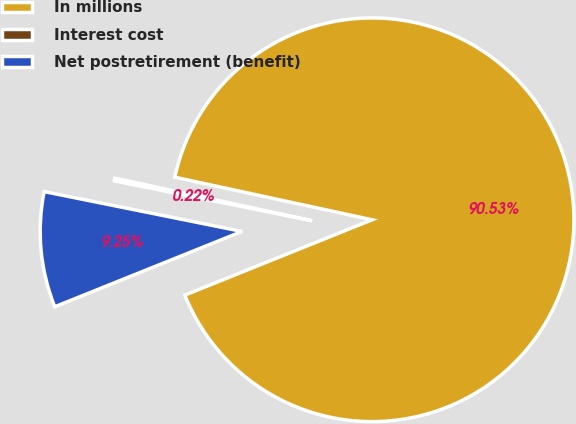Convert chart. <chart><loc_0><loc_0><loc_500><loc_500><pie_chart><fcel>In millions<fcel>Interest cost<fcel>Net postretirement (benefit)<nl><fcel>90.52%<fcel>0.22%<fcel>9.25%<nl></chart> 